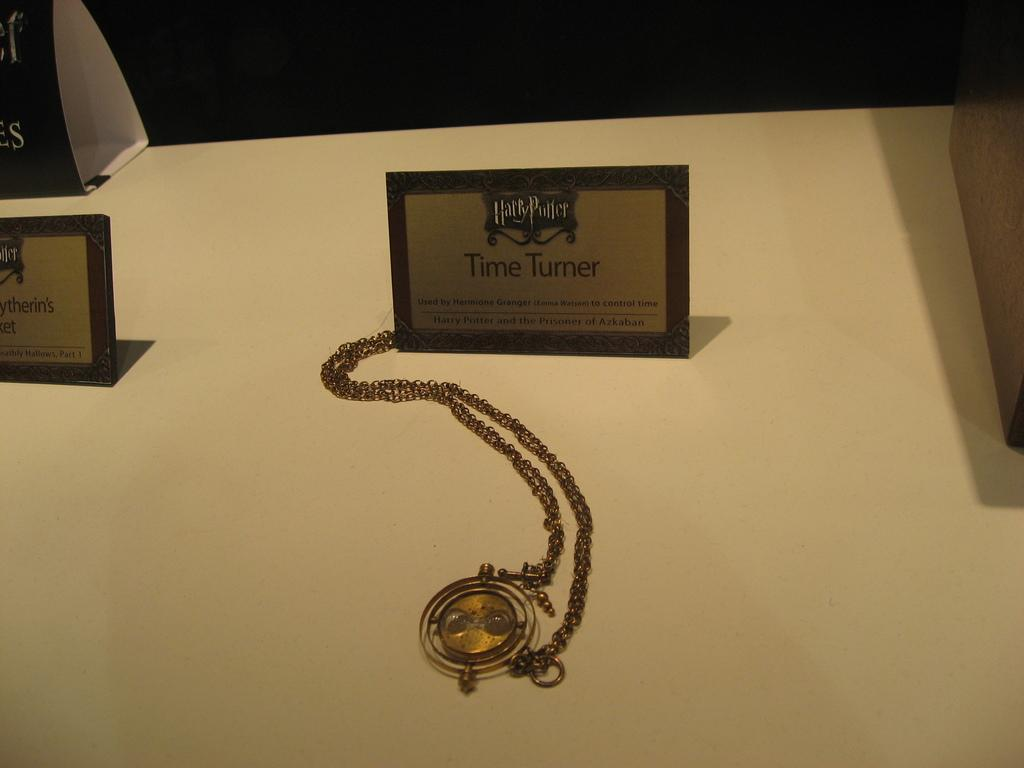<image>
Present a compact description of the photo's key features. A small plaque from Harry Potter witht he name Time Turner on it and a gold watch beside 